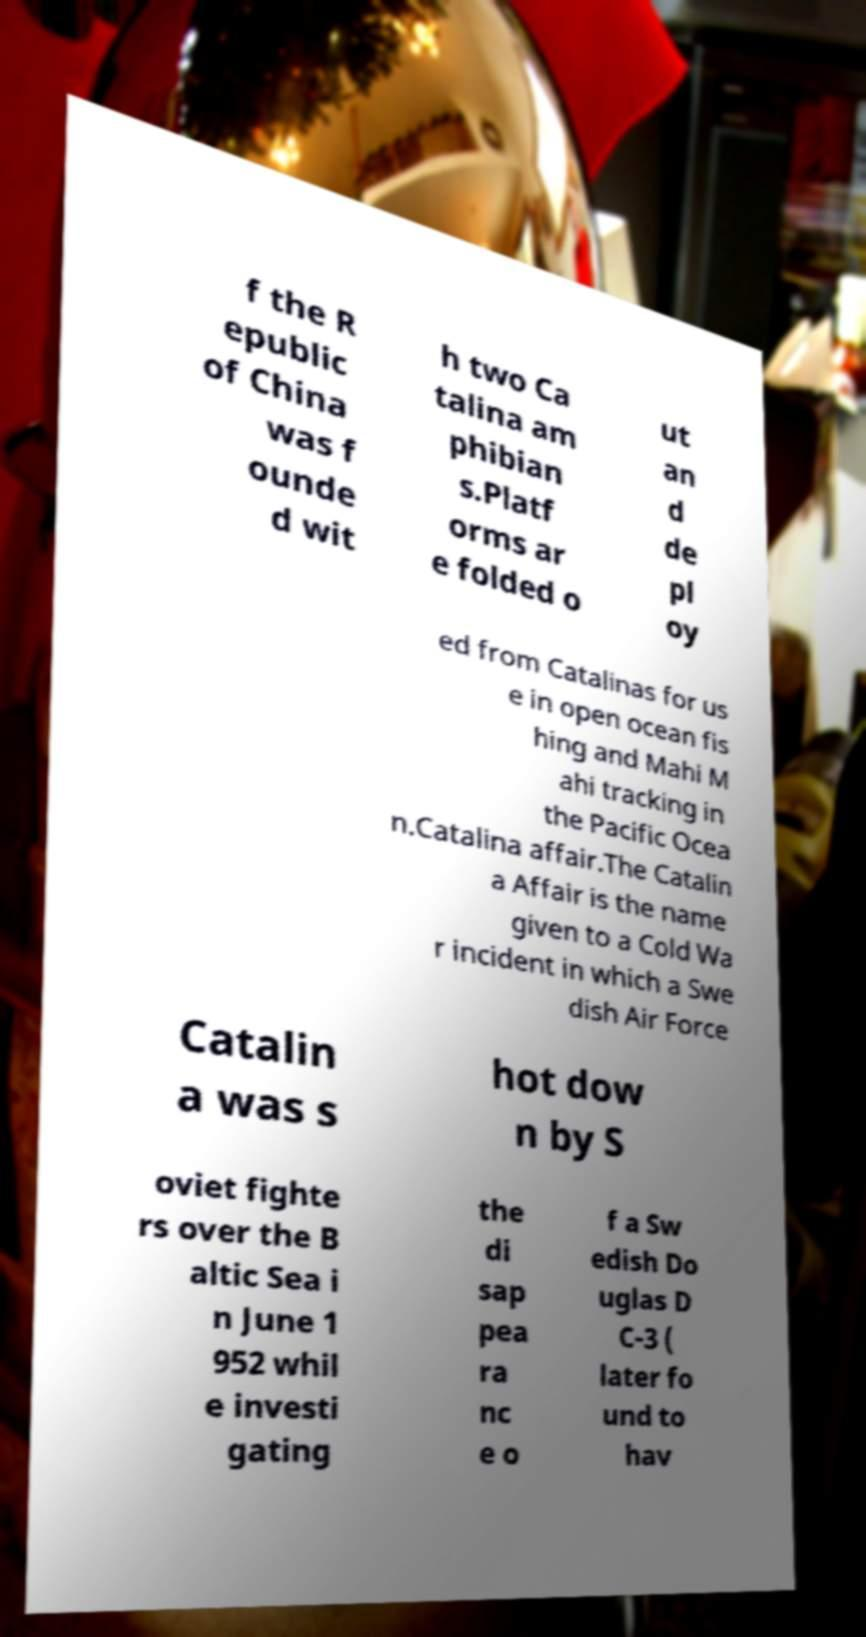I need the written content from this picture converted into text. Can you do that? f the R epublic of China was f ounde d wit h two Ca talina am phibian s.Platf orms ar e folded o ut an d de pl oy ed from Catalinas for us e in open ocean fis hing and Mahi M ahi tracking in the Pacific Ocea n.Catalina affair.The Catalin a Affair is the name given to a Cold Wa r incident in which a Swe dish Air Force Catalin a was s hot dow n by S oviet fighte rs over the B altic Sea i n June 1 952 whil e investi gating the di sap pea ra nc e o f a Sw edish Do uglas D C-3 ( later fo und to hav 